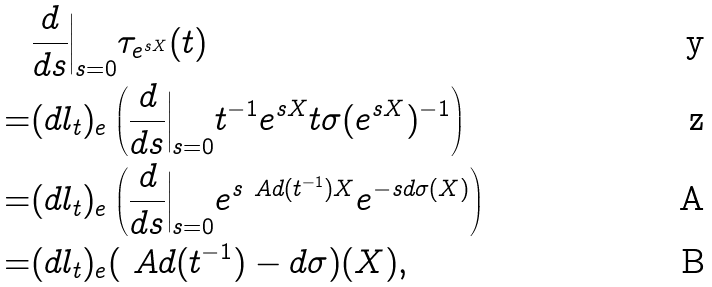Convert formula to latex. <formula><loc_0><loc_0><loc_500><loc_500>& \frac { d } { d s } \Big | _ { s = 0 } \tau _ { e ^ { s X } } ( t ) \\ = & ( d l _ { t } ) _ { e } \left ( \frac { d } { d s } \Big | _ { s = 0 } t ^ { - 1 } e ^ { s X } t \sigma ( e ^ { s X } ) ^ { - 1 } \right ) \\ = & ( d l _ { t } ) _ { e } \left ( \frac { d } { d s } \Big | _ { s = 0 } e ^ { s \ A d ( t ^ { - 1 } ) X } e ^ { - s d \sigma ( X ) } \right ) \\ = & ( d l _ { t } ) _ { e } ( \ A d ( t ^ { - 1 } ) - d \sigma ) ( X ) ,</formula> 